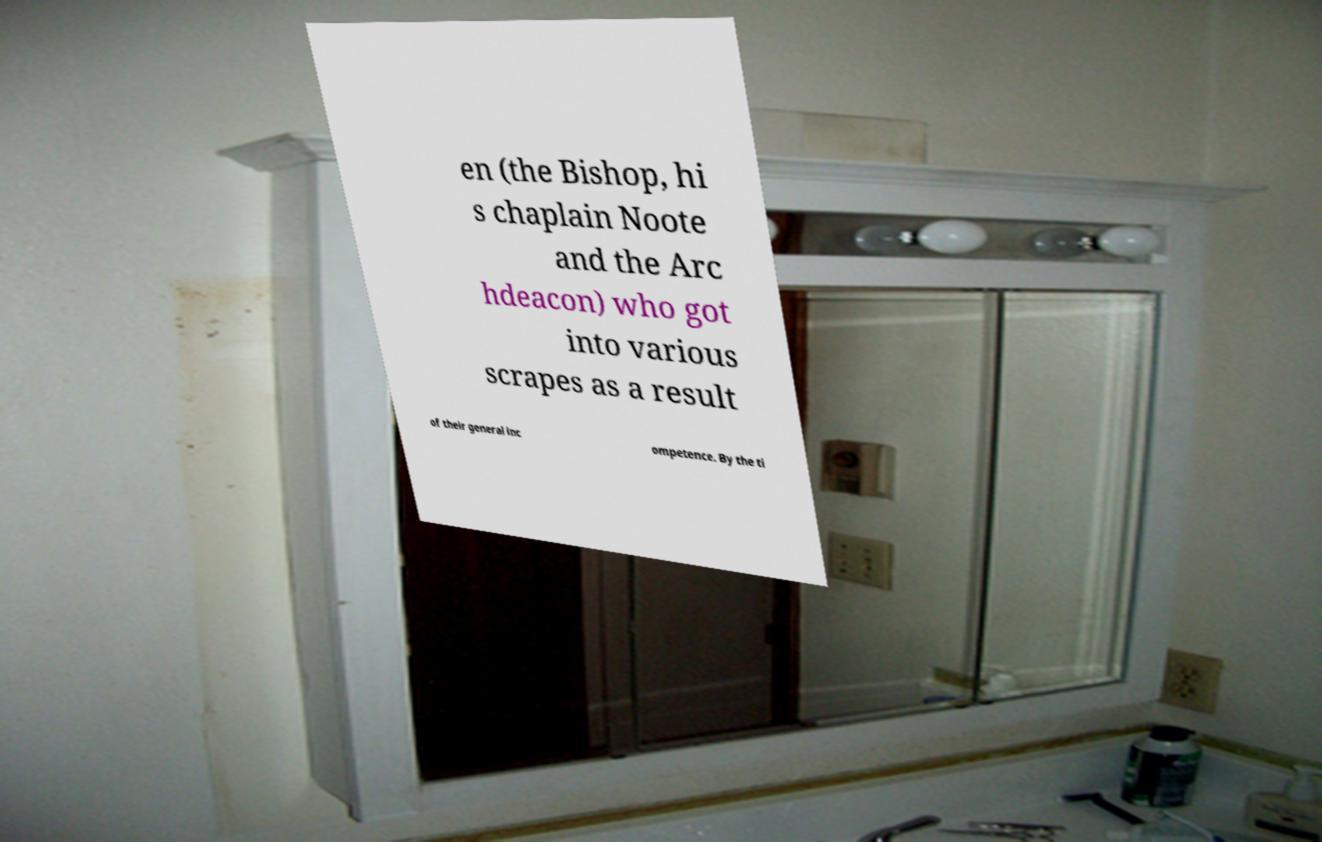Please read and relay the text visible in this image. What does it say? en (the Bishop, hi s chaplain Noote and the Arc hdeacon) who got into various scrapes as a result of their general inc ompetence. By the ti 